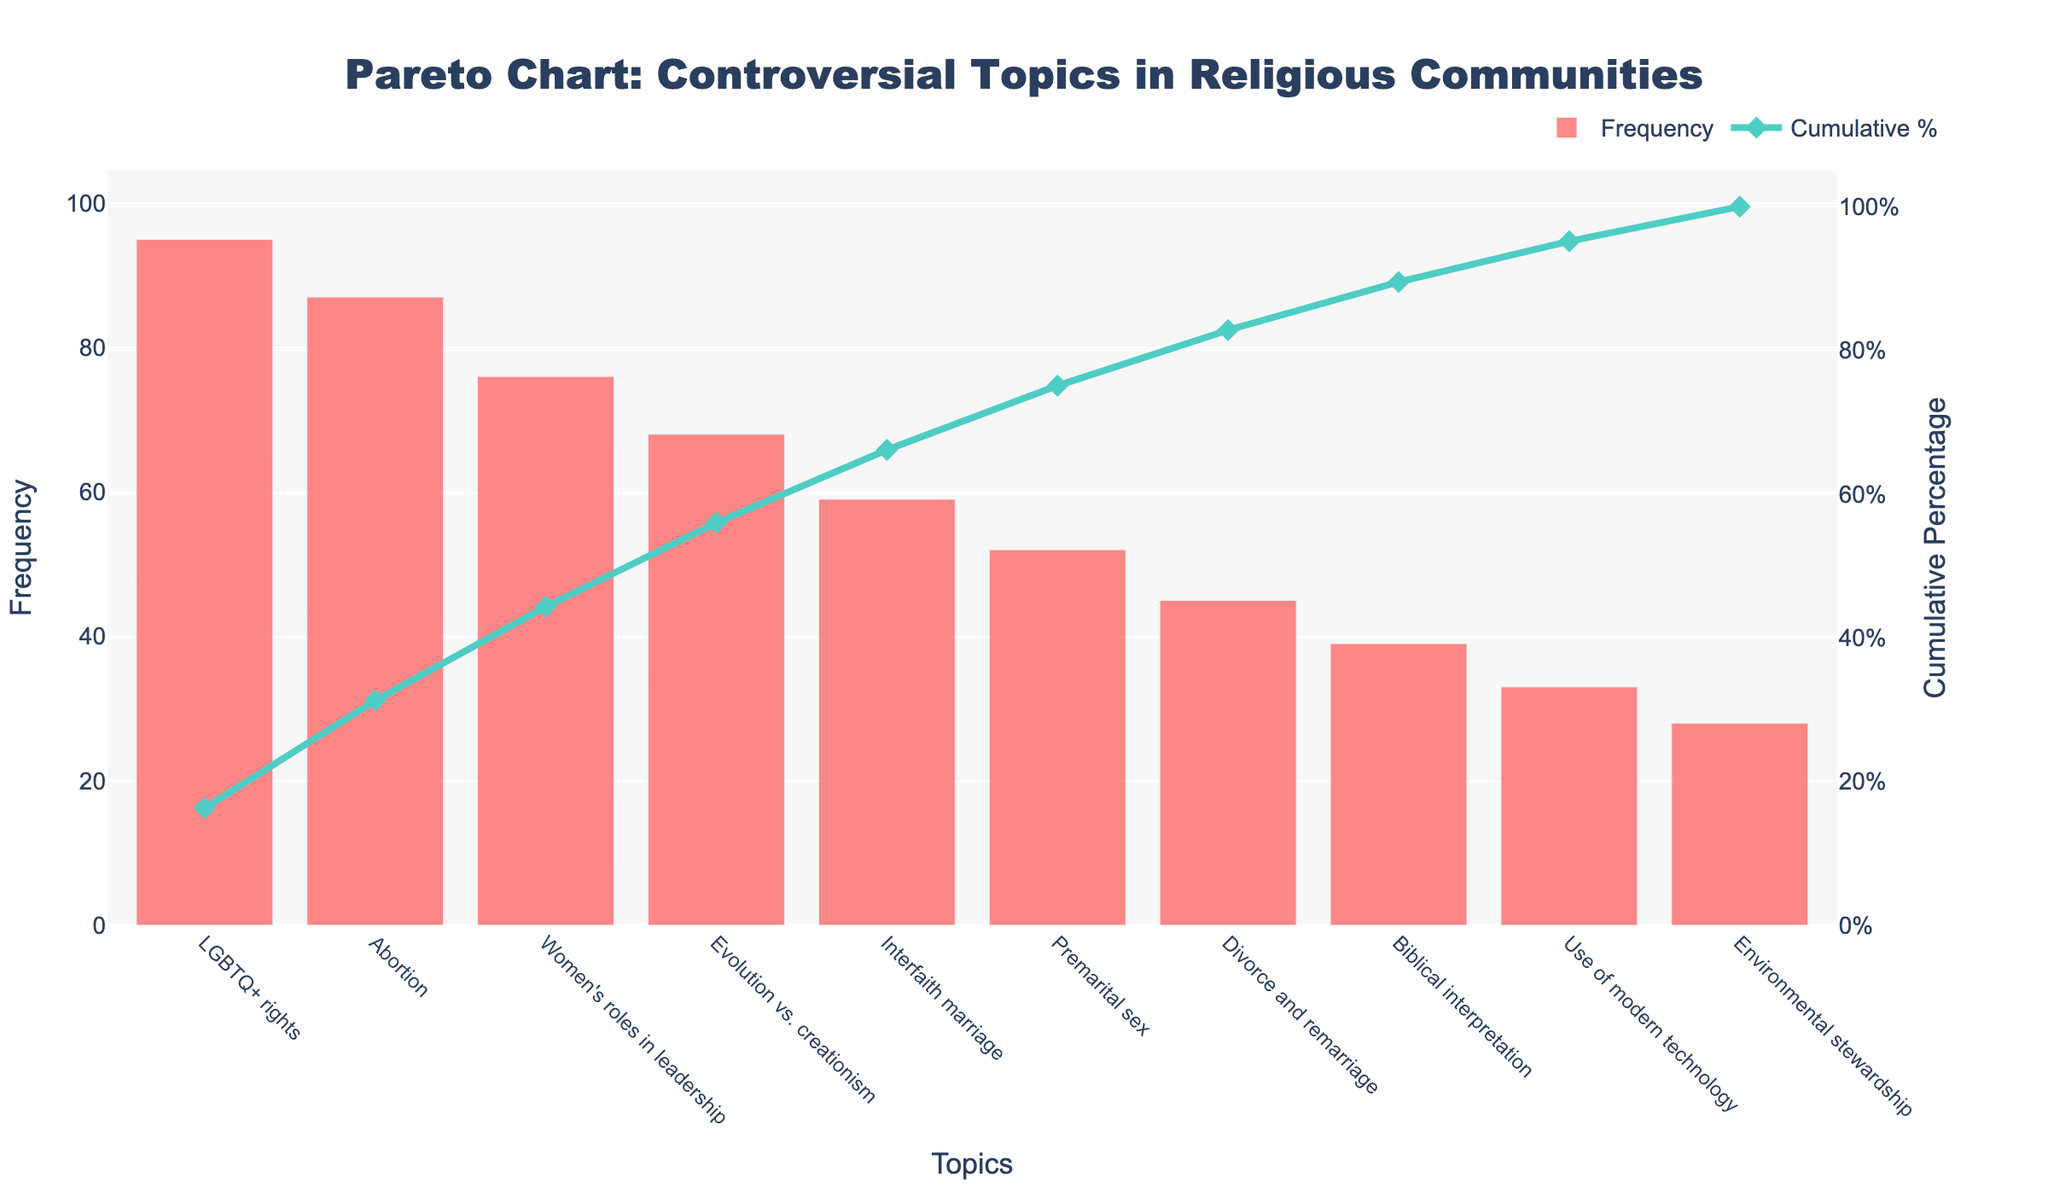What is the title of the chart? The title is usually displayed at the top of the chart and is easy to identify. In this case, it refers to the chart's purpose.
Answer: "Pareto Chart: Controversial Topics in Religious Communities" What topic has the highest frequency of debate? To determine the topic with the highest frequency, look at the tallest bar in the chart, which corresponds to the highest value on the y-axis labeled Frequency.
Answer: "LGBTQ+ rights" What is the cumulative percentage of the top three topics? To calculate the cumulative percentage for the top three topics, sum their frequencies and then divide by the total frequency of all topics, converting this fraction to a percentage. The top three topics are "LGBTQ+ rights," "Abortion," and "Women's roles in leadership," with frequencies of 95, 87, and 76 respectively. The sum is 95 + 87 + 76 = 258, and the total frequency of all topics is 582. The cumulative percentage is (258 / 582) * 100.
Answer: 44.33% Which topics have a cumulative percentage less than 50%? To find topics with a cumulative percentage less than 50%, look at the line chart overlay that represents the cumulative percentage and identify topics before this line crosses the 50% mark.
Answer: "LGBTQ+ rights," "Abortion," "Women's roles in leadership," "Evolution vs. creationism" Is "Premarital sex" more debated than "Interfaith marriage"? Compare the height of the bars representing these two topics. The taller bar indicates the topic with a higher frequency of debate.
Answer: No What is the exact frequency of the least debated topic? Look for the shortest bar and check its value along the y-axis labeled Frequency. The least debated topic is "Environmental stewardship," with a frequency of 28.
Answer: 28 By how much is the frequency of debate for "Abortion" higher than that for "Divorce and remarriage"? Subtract the frequency of "Divorce and remarriage" from "Abortion." The frequencies are 87 and 45 respectively. The difference is 87 - 45.
Answer: 42 How many topics have a frequency greater than 50? Count the bars that exceed the 50 mark on the y-axis labeled Frequency.
Answer: 5 What is the cumulative percentage of the most debated topic? The cumulative percentage values are shown for each topic. Find the value for the most debated topic, "LGBTQ+ rights."
Answer: 16.32% Which topic marks the point where the cumulative percentage surpasses 50%? Look at the line chart for the cumulative percentage and identify the first topic after the line crosses the 50% mark. The cumulative percentage crossing 50% happens with the topic "Women's roles in leadership."
Answer: "Women's roles in leadership" 